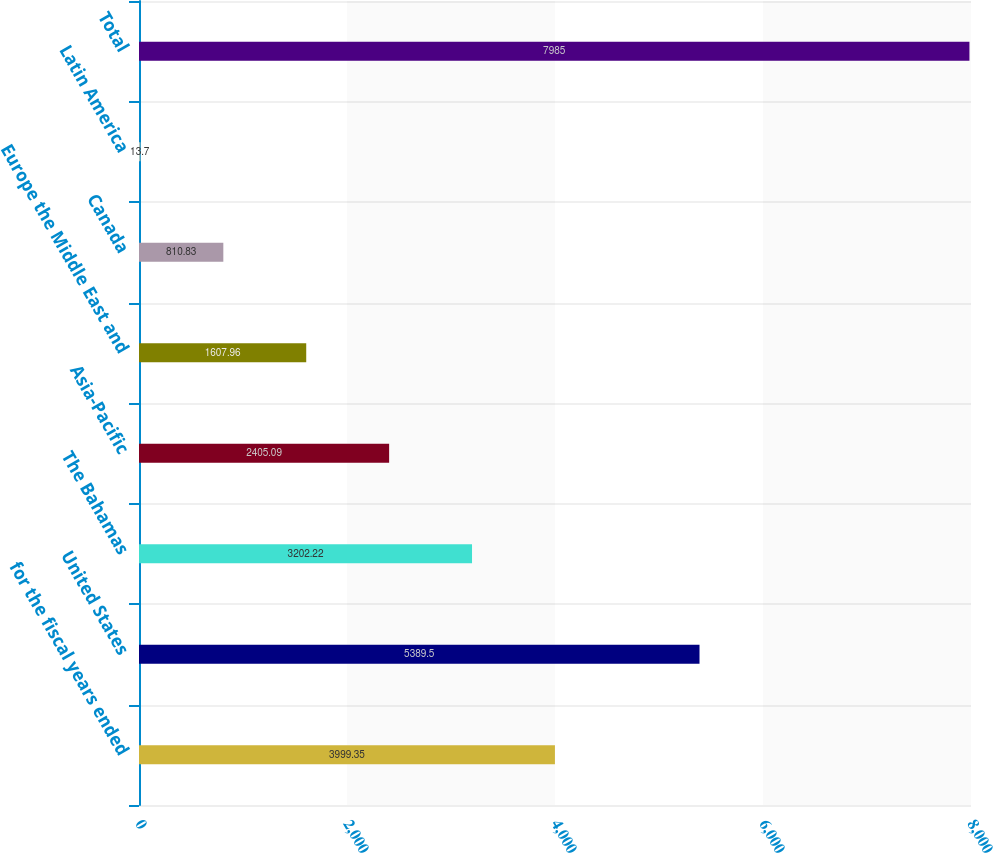Convert chart. <chart><loc_0><loc_0><loc_500><loc_500><bar_chart><fcel>for the fiscal years ended<fcel>United States<fcel>The Bahamas<fcel>Asia-Pacific<fcel>Europe the Middle East and<fcel>Canada<fcel>Latin America<fcel>Total<nl><fcel>3999.35<fcel>5389.5<fcel>3202.22<fcel>2405.09<fcel>1607.96<fcel>810.83<fcel>13.7<fcel>7985<nl></chart> 